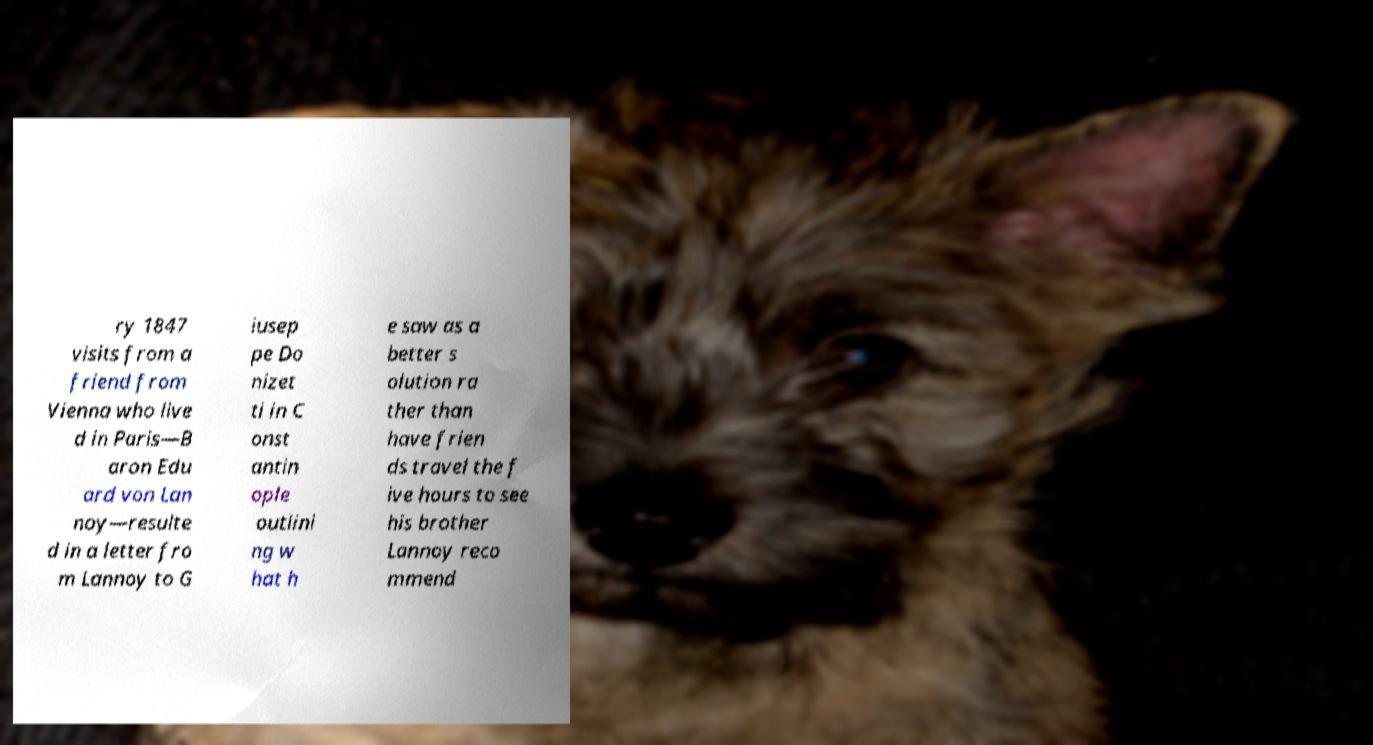Could you extract and type out the text from this image? ry 1847 visits from a friend from Vienna who live d in Paris—B aron Edu ard von Lan noy—resulte d in a letter fro m Lannoy to G iusep pe Do nizet ti in C onst antin ople outlini ng w hat h e saw as a better s olution ra ther than have frien ds travel the f ive hours to see his brother Lannoy reco mmend 